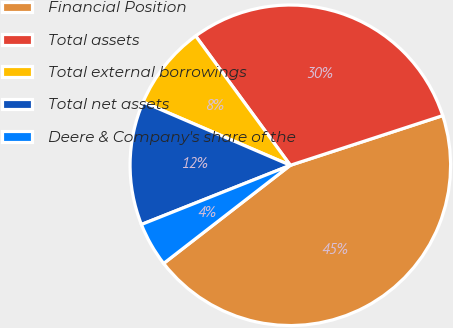Convert chart to OTSL. <chart><loc_0><loc_0><loc_500><loc_500><pie_chart><fcel>Financial Position<fcel>Total assets<fcel>Total external borrowings<fcel>Total net assets<fcel>Deere & Company's share of the<nl><fcel>44.52%<fcel>30.04%<fcel>8.48%<fcel>12.48%<fcel>4.47%<nl></chart> 